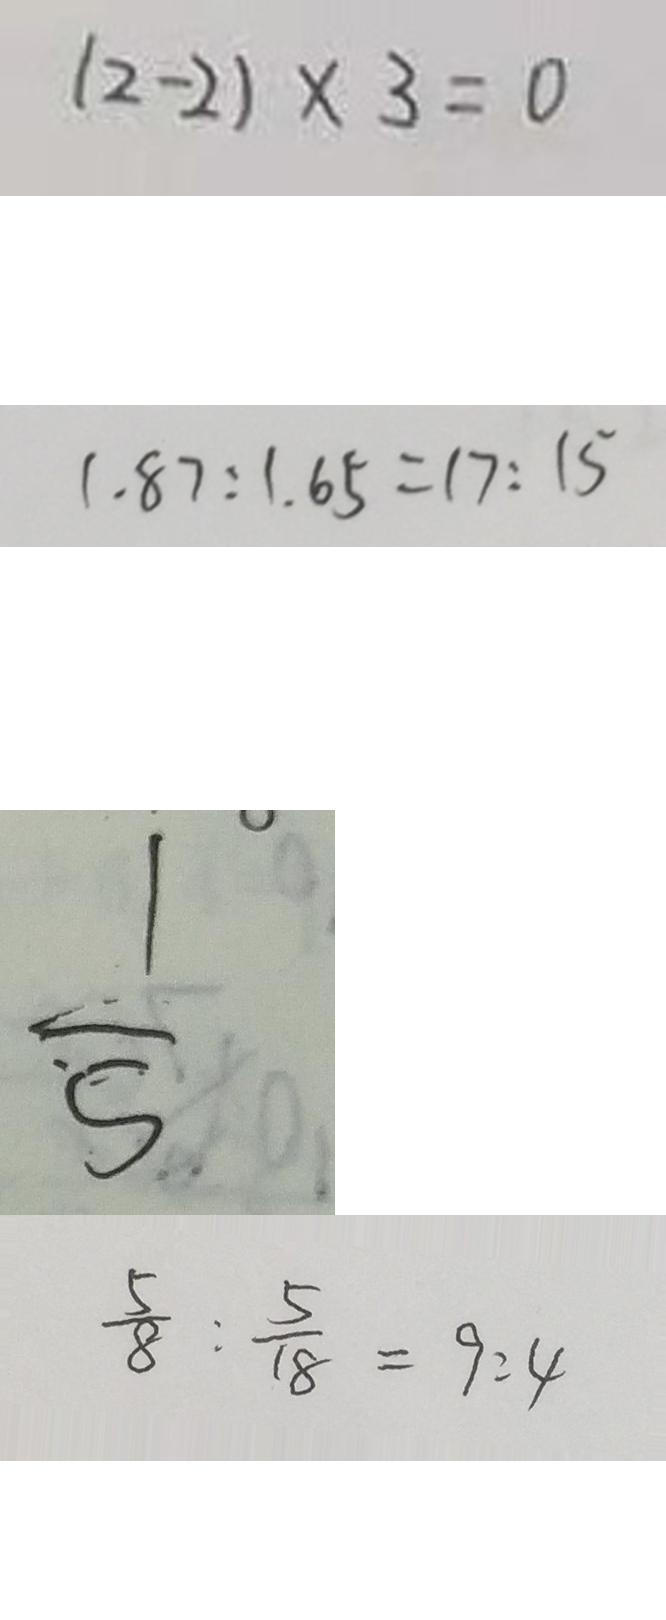Convert formula to latex. <formula><loc_0><loc_0><loc_500><loc_500>( 2 - 2 ) \times 3 = 0 
 1 . 8 7 : 1 . 6 5 = 1 7 : 1 5 
 \frac { 1 } { 5 } 
 \frac { 5 } { 8 } : \frac { 5 } { 1 8 } = 9 : 4</formula> 